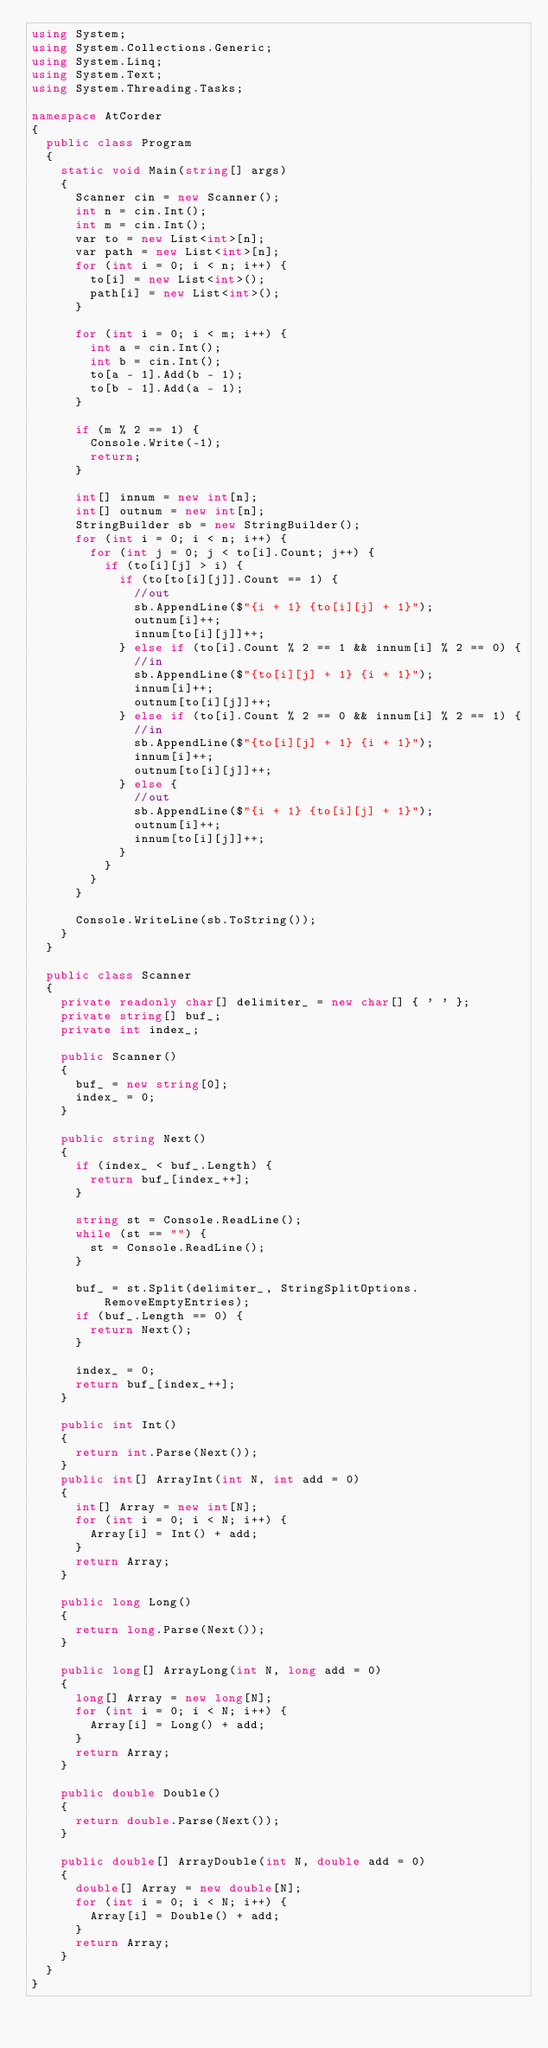<code> <loc_0><loc_0><loc_500><loc_500><_C#_>using System;
using System.Collections.Generic;
using System.Linq;
using System.Text;
using System.Threading.Tasks;

namespace AtCorder
{
	public class Program
	{
		static void Main(string[] args)
		{
			Scanner cin = new Scanner();
			int n = cin.Int();
			int m = cin.Int();
			var to = new List<int>[n];
			var path = new List<int>[n];
			for (int i = 0; i < n; i++) {
				to[i] = new List<int>();
				path[i] = new List<int>();
			}

			for (int i = 0; i < m; i++) {
				int a = cin.Int();
				int b = cin.Int();
				to[a - 1].Add(b - 1);
				to[b - 1].Add(a - 1);
			}

			if (m % 2 == 1) {
				Console.Write(-1);
				return;
			}

			int[] innum = new int[n];
			int[] outnum = new int[n];
			StringBuilder sb = new StringBuilder();
			for (int i = 0; i < n; i++) {
				for (int j = 0; j < to[i].Count; j++) {
					if (to[i][j] > i) {
						if (to[to[i][j]].Count == 1) {
							//out
							sb.AppendLine($"{i + 1} {to[i][j] + 1}");
							outnum[i]++;
							innum[to[i][j]]++;
						} else if (to[i].Count % 2 == 1 && innum[i] % 2 == 0) {
							//in
							sb.AppendLine($"{to[i][j] + 1} {i + 1}");
							innum[i]++;
							outnum[to[i][j]]++;
						} else if (to[i].Count % 2 == 0 && innum[i] % 2 == 1) {
							//in
							sb.AppendLine($"{to[i][j] + 1} {i + 1}");
							innum[i]++;
							outnum[to[i][j]]++;
						} else {
							//out
							sb.AppendLine($"{i + 1} {to[i][j] + 1}");
							outnum[i]++;
							innum[to[i][j]]++;
						}
					}
				}
			}

			Console.WriteLine(sb.ToString());
		}
	}

	public class Scanner
	{
		private readonly char[] delimiter_ = new char[] { ' ' };
		private string[] buf_;
		private int index_;
		
		public Scanner()
		{
			buf_ = new string[0];
			index_ = 0;
		}

		public string Next()
		{
			if (index_ < buf_.Length) {
				return buf_[index_++];
			}

			string st = Console.ReadLine();
			while (st == "") {
				st = Console.ReadLine();
			}

			buf_ = st.Split(delimiter_, StringSplitOptions.RemoveEmptyEntries);
			if (buf_.Length == 0) {
				return Next();
			}

			index_ = 0;
			return buf_[index_++];
		}

		public int Int()
		{
			return int.Parse(Next());
		}
		public int[] ArrayInt(int N, int add = 0)
		{
			int[] Array = new int[N];
			for (int i = 0; i < N; i++) {
				Array[i] = Int() + add;
			}
			return Array;
		}

		public long Long()
		{
			return long.Parse(Next());
		}

		public long[] ArrayLong(int N, long add = 0)
		{
			long[] Array = new long[N];
			for (int i = 0; i < N; i++) {
				Array[i] = Long() + add;
			}
			return Array;
		}

		public double Double()
		{
			return double.Parse(Next());
		}

		public double[] ArrayDouble(int N, double add = 0)
		{
			double[] Array = new double[N];
			for (int i = 0; i < N; i++) {
				Array[i] = Double() + add;
			}
			return Array;
		}
	}
}
</code> 